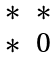<formula> <loc_0><loc_0><loc_500><loc_500>\begin{matrix} * & * \\ * & 0 \end{matrix}</formula> 